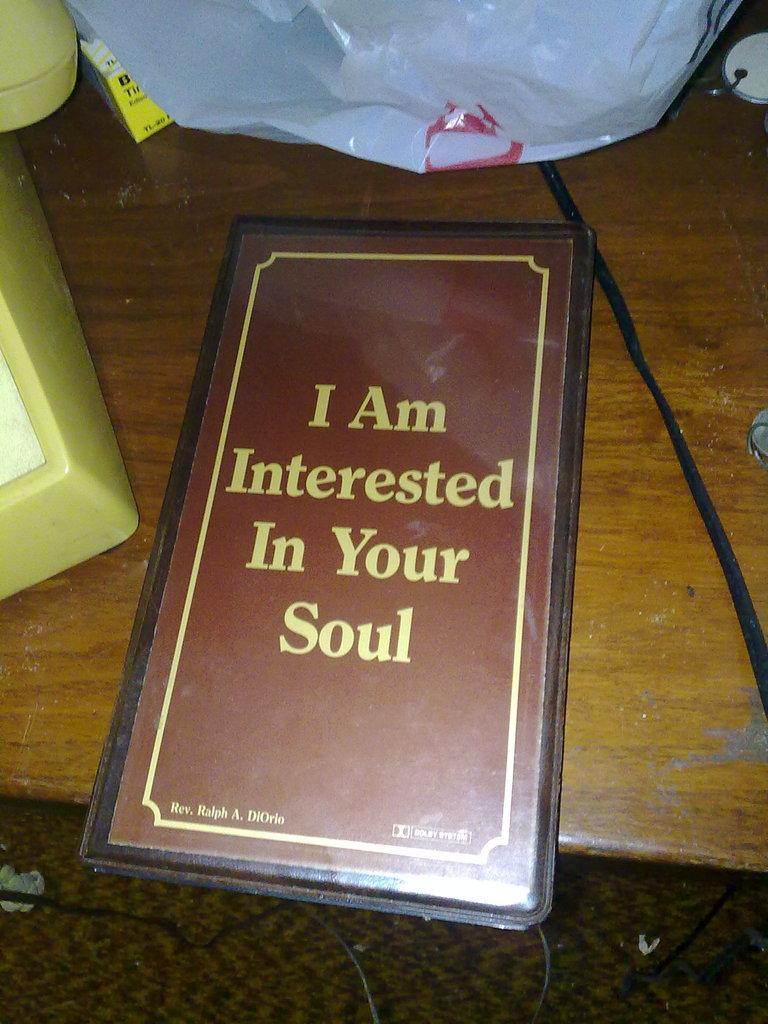Provide a one-sentence caption for the provided image. A menu with the wording "I am interested in your soul" is on a table. 